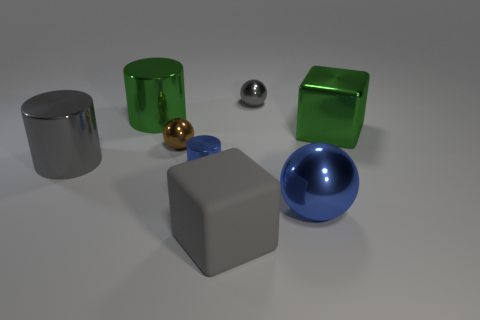What color is the shiny object that is to the right of the large green cylinder and to the left of the small blue object?
Ensure brevity in your answer.  Brown. The rubber object that is the same size as the green metal cylinder is what shape?
Keep it short and to the point. Cube. Are there any other things of the same shape as the big blue thing?
Offer a very short reply. Yes. Is the size of the gray shiny object to the left of the gray block the same as the gray matte block?
Ensure brevity in your answer.  Yes. How big is the shiny object that is left of the gray cube and on the right side of the small brown shiny sphere?
Your response must be concise. Small. How many other things are there of the same material as the brown ball?
Offer a terse response. 6. What size is the shiny sphere in front of the blue metal cylinder?
Offer a terse response. Large. Do the big ball and the tiny shiny cylinder have the same color?
Your response must be concise. Yes. What number of large objects are green blocks or green cylinders?
Keep it short and to the point. 2. Are there any other things that have the same color as the big rubber object?
Your answer should be compact. Yes. 